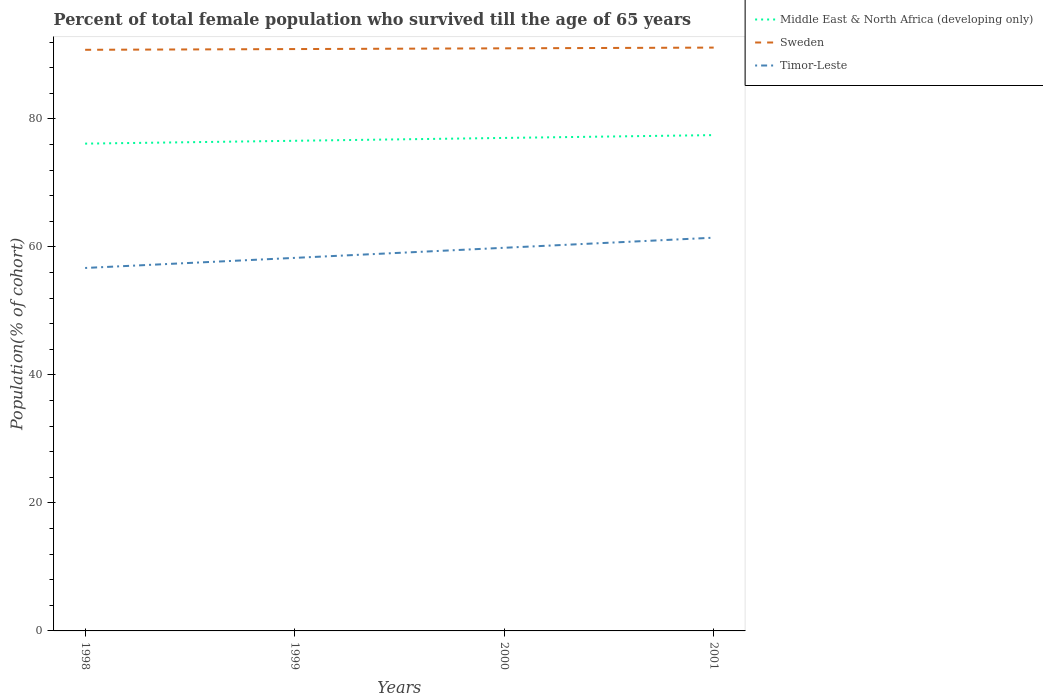Does the line corresponding to Timor-Leste intersect with the line corresponding to Sweden?
Keep it short and to the point. No. Across all years, what is the maximum percentage of total female population who survived till the age of 65 years in Middle East & North Africa (developing only)?
Make the answer very short. 76.13. In which year was the percentage of total female population who survived till the age of 65 years in Timor-Leste maximum?
Your answer should be compact. 1998. What is the total percentage of total female population who survived till the age of 65 years in Timor-Leste in the graph?
Offer a terse response. -3.15. What is the difference between the highest and the second highest percentage of total female population who survived till the age of 65 years in Sweden?
Provide a succinct answer. 0.34. Are the values on the major ticks of Y-axis written in scientific E-notation?
Ensure brevity in your answer.  No. Does the graph contain any zero values?
Provide a succinct answer. No. Does the graph contain grids?
Give a very brief answer. No. Where does the legend appear in the graph?
Provide a short and direct response. Top right. How many legend labels are there?
Offer a very short reply. 3. How are the legend labels stacked?
Offer a terse response. Vertical. What is the title of the graph?
Offer a terse response. Percent of total female population who survived till the age of 65 years. Does "Australia" appear as one of the legend labels in the graph?
Ensure brevity in your answer.  No. What is the label or title of the X-axis?
Offer a very short reply. Years. What is the label or title of the Y-axis?
Give a very brief answer. Population(% of cohort). What is the Population(% of cohort) in Middle East & North Africa (developing only) in 1998?
Your response must be concise. 76.13. What is the Population(% of cohort) in Sweden in 1998?
Your answer should be very brief. 90.79. What is the Population(% of cohort) of Timor-Leste in 1998?
Ensure brevity in your answer.  56.7. What is the Population(% of cohort) in Middle East & North Africa (developing only) in 1999?
Provide a short and direct response. 76.57. What is the Population(% of cohort) in Sweden in 1999?
Your response must be concise. 90.9. What is the Population(% of cohort) of Timor-Leste in 1999?
Ensure brevity in your answer.  58.28. What is the Population(% of cohort) in Middle East & North Africa (developing only) in 2000?
Offer a terse response. 77.02. What is the Population(% of cohort) of Sweden in 2000?
Keep it short and to the point. 91.02. What is the Population(% of cohort) in Timor-Leste in 2000?
Ensure brevity in your answer.  59.86. What is the Population(% of cohort) in Middle East & North Africa (developing only) in 2001?
Your response must be concise. 77.46. What is the Population(% of cohort) of Sweden in 2001?
Offer a terse response. 91.13. What is the Population(% of cohort) in Timor-Leste in 2001?
Your answer should be very brief. 61.44. Across all years, what is the maximum Population(% of cohort) of Middle East & North Africa (developing only)?
Offer a very short reply. 77.46. Across all years, what is the maximum Population(% of cohort) of Sweden?
Give a very brief answer. 91.13. Across all years, what is the maximum Population(% of cohort) of Timor-Leste?
Your response must be concise. 61.44. Across all years, what is the minimum Population(% of cohort) in Middle East & North Africa (developing only)?
Your answer should be very brief. 76.13. Across all years, what is the minimum Population(% of cohort) in Sweden?
Keep it short and to the point. 90.79. Across all years, what is the minimum Population(% of cohort) of Timor-Leste?
Offer a terse response. 56.7. What is the total Population(% of cohort) in Middle East & North Africa (developing only) in the graph?
Keep it short and to the point. 307.19. What is the total Population(% of cohort) in Sweden in the graph?
Make the answer very short. 363.84. What is the total Population(% of cohort) in Timor-Leste in the graph?
Offer a terse response. 236.28. What is the difference between the Population(% of cohort) of Middle East & North Africa (developing only) in 1998 and that in 1999?
Offer a very short reply. -0.44. What is the difference between the Population(% of cohort) in Sweden in 1998 and that in 1999?
Offer a terse response. -0.11. What is the difference between the Population(% of cohort) in Timor-Leste in 1998 and that in 1999?
Provide a short and direct response. -1.58. What is the difference between the Population(% of cohort) in Middle East & North Africa (developing only) in 1998 and that in 2000?
Make the answer very short. -0.89. What is the difference between the Population(% of cohort) in Sweden in 1998 and that in 2000?
Ensure brevity in your answer.  -0.23. What is the difference between the Population(% of cohort) in Timor-Leste in 1998 and that in 2000?
Offer a very short reply. -3.15. What is the difference between the Population(% of cohort) of Middle East & North Africa (developing only) in 1998 and that in 2001?
Your answer should be compact. -1.33. What is the difference between the Population(% of cohort) of Sweden in 1998 and that in 2001?
Keep it short and to the point. -0.34. What is the difference between the Population(% of cohort) of Timor-Leste in 1998 and that in 2001?
Offer a terse response. -4.73. What is the difference between the Population(% of cohort) in Middle East & North Africa (developing only) in 1999 and that in 2000?
Offer a very short reply. -0.45. What is the difference between the Population(% of cohort) of Sweden in 1999 and that in 2000?
Make the answer very short. -0.11. What is the difference between the Population(% of cohort) in Timor-Leste in 1999 and that in 2000?
Make the answer very short. -1.58. What is the difference between the Population(% of cohort) in Middle East & North Africa (developing only) in 1999 and that in 2001?
Your answer should be compact. -0.89. What is the difference between the Population(% of cohort) of Sweden in 1999 and that in 2001?
Offer a very short reply. -0.23. What is the difference between the Population(% of cohort) in Timor-Leste in 1999 and that in 2001?
Give a very brief answer. -3.15. What is the difference between the Population(% of cohort) of Middle East & North Africa (developing only) in 2000 and that in 2001?
Provide a short and direct response. -0.44. What is the difference between the Population(% of cohort) of Sweden in 2000 and that in 2001?
Give a very brief answer. -0.11. What is the difference between the Population(% of cohort) in Timor-Leste in 2000 and that in 2001?
Keep it short and to the point. -1.58. What is the difference between the Population(% of cohort) of Middle East & North Africa (developing only) in 1998 and the Population(% of cohort) of Sweden in 1999?
Provide a short and direct response. -14.77. What is the difference between the Population(% of cohort) of Middle East & North Africa (developing only) in 1998 and the Population(% of cohort) of Timor-Leste in 1999?
Your answer should be compact. 17.85. What is the difference between the Population(% of cohort) in Sweden in 1998 and the Population(% of cohort) in Timor-Leste in 1999?
Provide a succinct answer. 32.51. What is the difference between the Population(% of cohort) of Middle East & North Africa (developing only) in 1998 and the Population(% of cohort) of Sweden in 2000?
Make the answer very short. -14.89. What is the difference between the Population(% of cohort) of Middle East & North Africa (developing only) in 1998 and the Population(% of cohort) of Timor-Leste in 2000?
Offer a terse response. 16.27. What is the difference between the Population(% of cohort) in Sweden in 1998 and the Population(% of cohort) in Timor-Leste in 2000?
Offer a terse response. 30.93. What is the difference between the Population(% of cohort) of Middle East & North Africa (developing only) in 1998 and the Population(% of cohort) of Sweden in 2001?
Provide a succinct answer. -15. What is the difference between the Population(% of cohort) of Middle East & North Africa (developing only) in 1998 and the Population(% of cohort) of Timor-Leste in 2001?
Make the answer very short. 14.69. What is the difference between the Population(% of cohort) of Sweden in 1998 and the Population(% of cohort) of Timor-Leste in 2001?
Ensure brevity in your answer.  29.35. What is the difference between the Population(% of cohort) in Middle East & North Africa (developing only) in 1999 and the Population(% of cohort) in Sweden in 2000?
Your answer should be very brief. -14.44. What is the difference between the Population(% of cohort) of Middle East & North Africa (developing only) in 1999 and the Population(% of cohort) of Timor-Leste in 2000?
Provide a succinct answer. 16.72. What is the difference between the Population(% of cohort) in Sweden in 1999 and the Population(% of cohort) in Timor-Leste in 2000?
Ensure brevity in your answer.  31.05. What is the difference between the Population(% of cohort) of Middle East & North Africa (developing only) in 1999 and the Population(% of cohort) of Sweden in 2001?
Offer a very short reply. -14.56. What is the difference between the Population(% of cohort) in Middle East & North Africa (developing only) in 1999 and the Population(% of cohort) in Timor-Leste in 2001?
Your answer should be very brief. 15.14. What is the difference between the Population(% of cohort) in Sweden in 1999 and the Population(% of cohort) in Timor-Leste in 2001?
Provide a short and direct response. 29.47. What is the difference between the Population(% of cohort) of Middle East & North Africa (developing only) in 2000 and the Population(% of cohort) of Sweden in 2001?
Provide a succinct answer. -14.11. What is the difference between the Population(% of cohort) in Middle East & North Africa (developing only) in 2000 and the Population(% of cohort) in Timor-Leste in 2001?
Make the answer very short. 15.58. What is the difference between the Population(% of cohort) in Sweden in 2000 and the Population(% of cohort) in Timor-Leste in 2001?
Give a very brief answer. 29.58. What is the average Population(% of cohort) of Middle East & North Africa (developing only) per year?
Your answer should be compact. 76.8. What is the average Population(% of cohort) in Sweden per year?
Ensure brevity in your answer.  90.96. What is the average Population(% of cohort) in Timor-Leste per year?
Give a very brief answer. 59.07. In the year 1998, what is the difference between the Population(% of cohort) of Middle East & North Africa (developing only) and Population(% of cohort) of Sweden?
Ensure brevity in your answer.  -14.66. In the year 1998, what is the difference between the Population(% of cohort) of Middle East & North Africa (developing only) and Population(% of cohort) of Timor-Leste?
Provide a short and direct response. 19.43. In the year 1998, what is the difference between the Population(% of cohort) in Sweden and Population(% of cohort) in Timor-Leste?
Provide a succinct answer. 34.09. In the year 1999, what is the difference between the Population(% of cohort) of Middle East & North Africa (developing only) and Population(% of cohort) of Sweden?
Your answer should be very brief. -14.33. In the year 1999, what is the difference between the Population(% of cohort) of Middle East & North Africa (developing only) and Population(% of cohort) of Timor-Leste?
Ensure brevity in your answer.  18.29. In the year 1999, what is the difference between the Population(% of cohort) in Sweden and Population(% of cohort) in Timor-Leste?
Ensure brevity in your answer.  32.62. In the year 2000, what is the difference between the Population(% of cohort) in Middle East & North Africa (developing only) and Population(% of cohort) in Sweden?
Ensure brevity in your answer.  -14. In the year 2000, what is the difference between the Population(% of cohort) in Middle East & North Africa (developing only) and Population(% of cohort) in Timor-Leste?
Offer a terse response. 17.16. In the year 2000, what is the difference between the Population(% of cohort) in Sweden and Population(% of cohort) in Timor-Leste?
Your answer should be very brief. 31.16. In the year 2001, what is the difference between the Population(% of cohort) of Middle East & North Africa (developing only) and Population(% of cohort) of Sweden?
Make the answer very short. -13.67. In the year 2001, what is the difference between the Population(% of cohort) of Middle East & North Africa (developing only) and Population(% of cohort) of Timor-Leste?
Your answer should be very brief. 16.03. In the year 2001, what is the difference between the Population(% of cohort) of Sweden and Population(% of cohort) of Timor-Leste?
Ensure brevity in your answer.  29.7. What is the ratio of the Population(% of cohort) of Sweden in 1998 to that in 1999?
Give a very brief answer. 1. What is the ratio of the Population(% of cohort) of Timor-Leste in 1998 to that in 1999?
Provide a succinct answer. 0.97. What is the ratio of the Population(% of cohort) of Middle East & North Africa (developing only) in 1998 to that in 2000?
Offer a very short reply. 0.99. What is the ratio of the Population(% of cohort) in Timor-Leste in 1998 to that in 2000?
Provide a short and direct response. 0.95. What is the ratio of the Population(% of cohort) of Middle East & North Africa (developing only) in 1998 to that in 2001?
Your response must be concise. 0.98. What is the ratio of the Population(% of cohort) in Timor-Leste in 1998 to that in 2001?
Keep it short and to the point. 0.92. What is the ratio of the Population(% of cohort) in Sweden in 1999 to that in 2000?
Offer a very short reply. 1. What is the ratio of the Population(% of cohort) in Timor-Leste in 1999 to that in 2000?
Offer a terse response. 0.97. What is the ratio of the Population(% of cohort) of Sweden in 1999 to that in 2001?
Make the answer very short. 1. What is the ratio of the Population(% of cohort) in Timor-Leste in 1999 to that in 2001?
Give a very brief answer. 0.95. What is the ratio of the Population(% of cohort) in Middle East & North Africa (developing only) in 2000 to that in 2001?
Provide a short and direct response. 0.99. What is the ratio of the Population(% of cohort) in Sweden in 2000 to that in 2001?
Your answer should be compact. 1. What is the ratio of the Population(% of cohort) of Timor-Leste in 2000 to that in 2001?
Provide a short and direct response. 0.97. What is the difference between the highest and the second highest Population(% of cohort) of Middle East & North Africa (developing only)?
Provide a short and direct response. 0.44. What is the difference between the highest and the second highest Population(% of cohort) in Sweden?
Keep it short and to the point. 0.11. What is the difference between the highest and the second highest Population(% of cohort) of Timor-Leste?
Your answer should be compact. 1.58. What is the difference between the highest and the lowest Population(% of cohort) in Middle East & North Africa (developing only)?
Ensure brevity in your answer.  1.33. What is the difference between the highest and the lowest Population(% of cohort) in Sweden?
Your answer should be compact. 0.34. What is the difference between the highest and the lowest Population(% of cohort) of Timor-Leste?
Offer a very short reply. 4.73. 